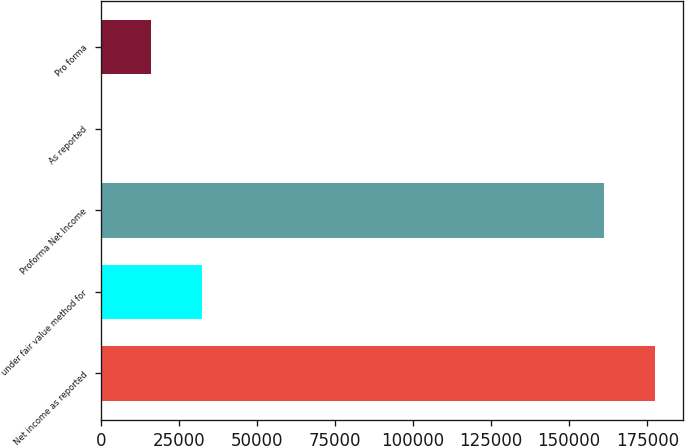Convert chart to OTSL. <chart><loc_0><loc_0><loc_500><loc_500><bar_chart><fcel>Net income as reported<fcel>under fair value method for<fcel>Proforma Net Income<fcel>As reported<fcel>Pro forma<nl><fcel>177479<fcel>32383.2<fcel>161288<fcel>1.19<fcel>16192.2<nl></chart> 